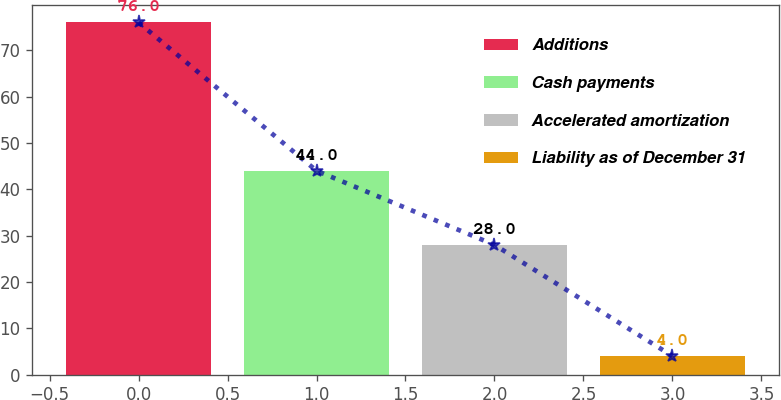<chart> <loc_0><loc_0><loc_500><loc_500><bar_chart><fcel>Additions<fcel>Cash payments<fcel>Accelerated amortization<fcel>Liability as of December 31<nl><fcel>76<fcel>44<fcel>28<fcel>4<nl></chart> 